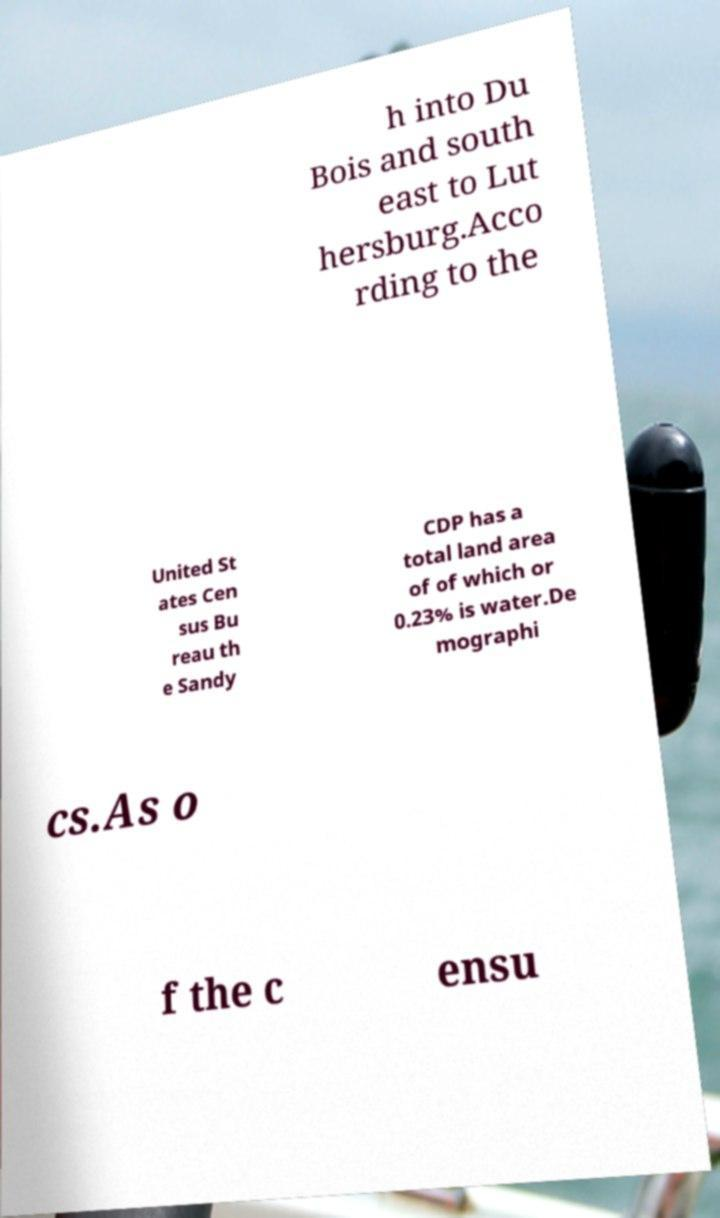Can you accurately transcribe the text from the provided image for me? h into Du Bois and south east to Lut hersburg.Acco rding to the United St ates Cen sus Bu reau th e Sandy CDP has a total land area of of which or 0.23% is water.De mographi cs.As o f the c ensu 